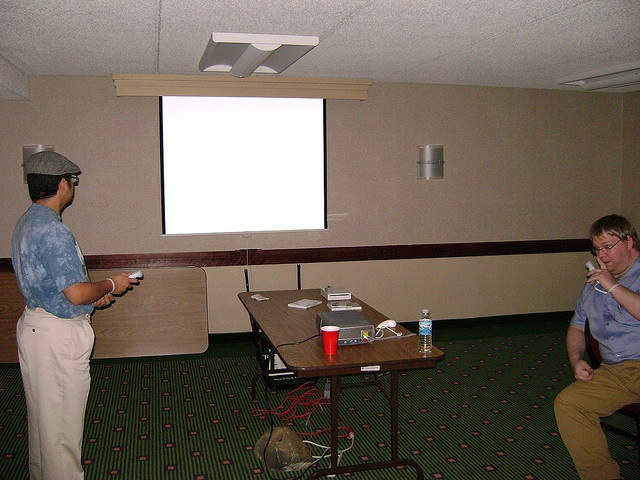Describe the objects in this image and their specific colors. I can see people in gray, darkgray, and black tones, people in gray, maroon, and black tones, dining table in gray, maroon, and black tones, dining table in gray and maroon tones, and bottle in gray, black, olive, and darkgray tones in this image. 